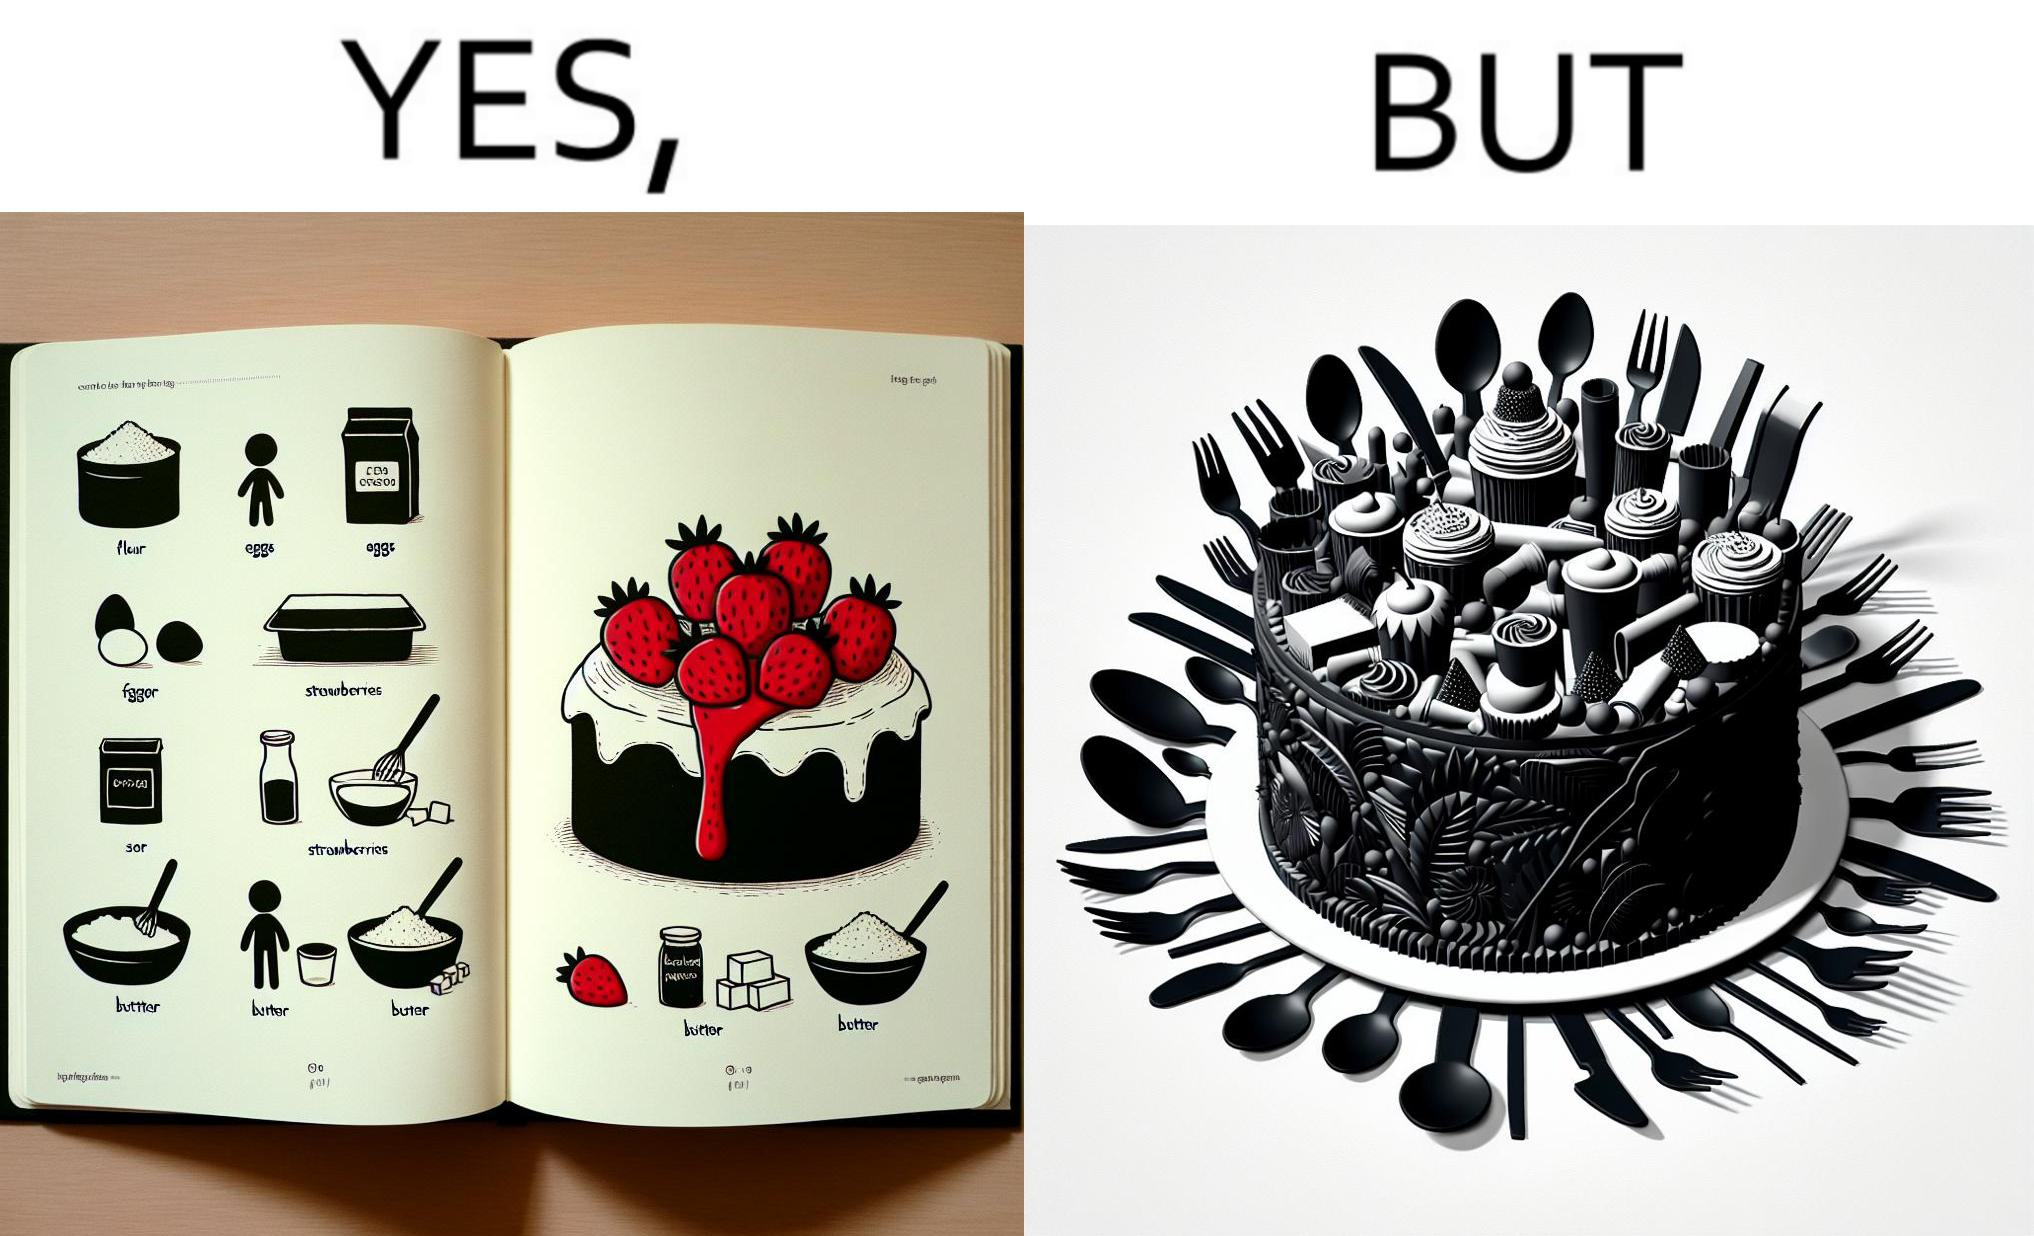Describe what you see in this image. The image is funny, as when making a strawberry cake using  a recipe book, the outcome is not quite what is expected, and one has to wash the used utensils afterwards as well. 